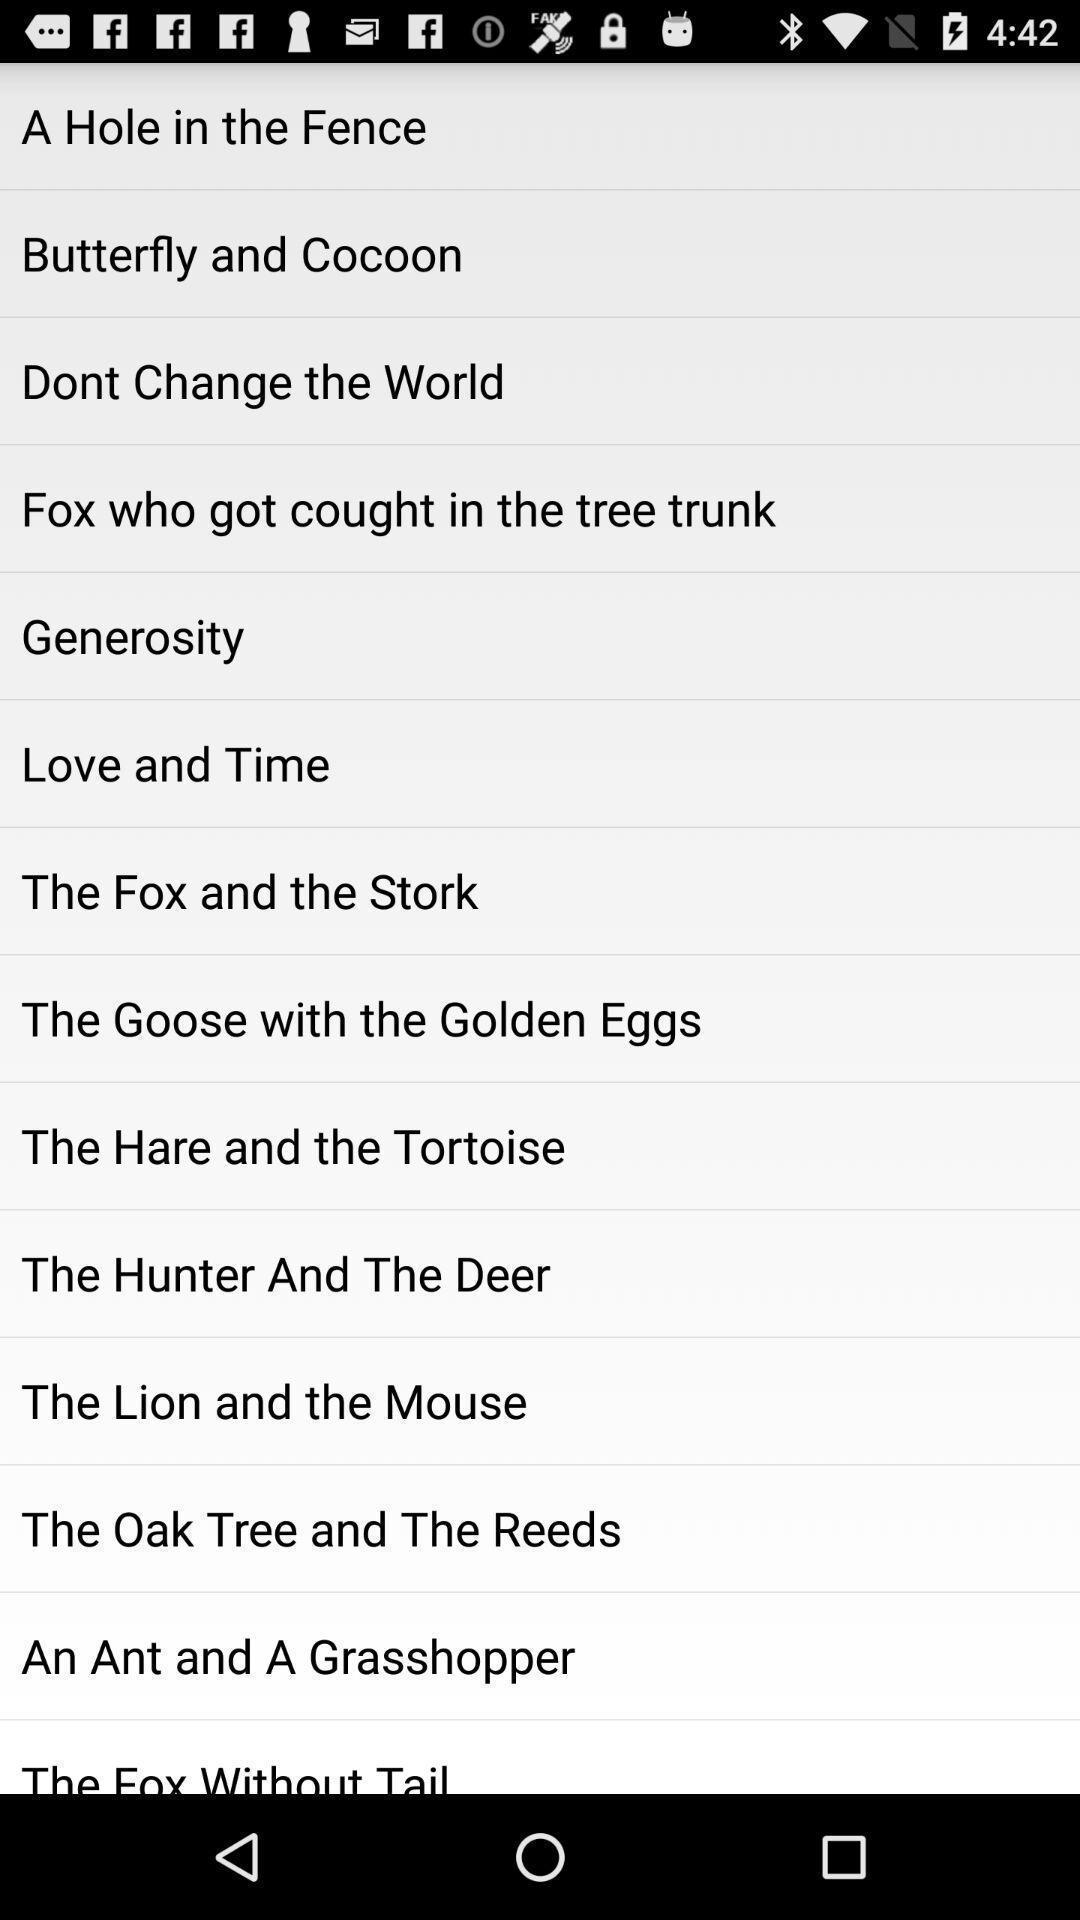Give me a summary of this screen capture. Screen showing multiple topics. 